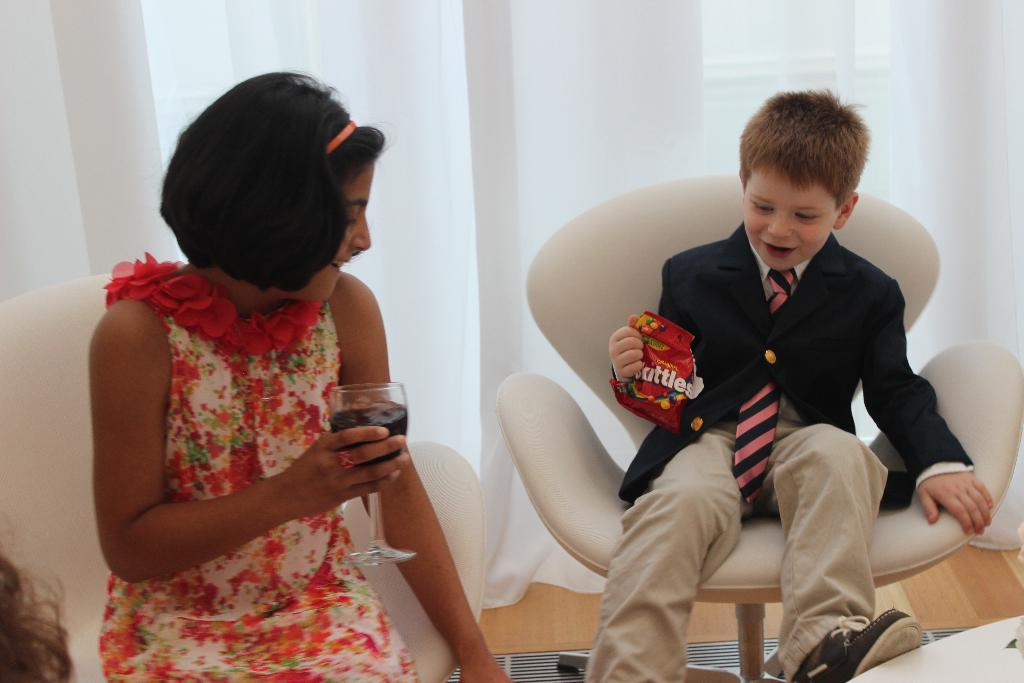How many people are in the image? There are two people in the image. What are the people holding in the image? The people are holding a glass and a packet. What are the people doing in the image? The people are sitting on chairs. What can be seen in the background of the image? There is a floor and a window with curtains visible in the background. What type of corn is growing in the image? There is no corn present in the image. What kind of plant is being traded between the two people in the image? There is no plant or trade activity depicted in the image. 